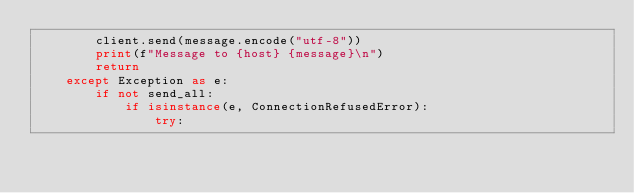<code> <loc_0><loc_0><loc_500><loc_500><_Python_>        client.send(message.encode("utf-8"))
        print(f"Message to {host} {message}\n")
        return
    except Exception as e:
        if not send_all:
            if isinstance(e, ConnectionRefusedError):
                try:</code> 